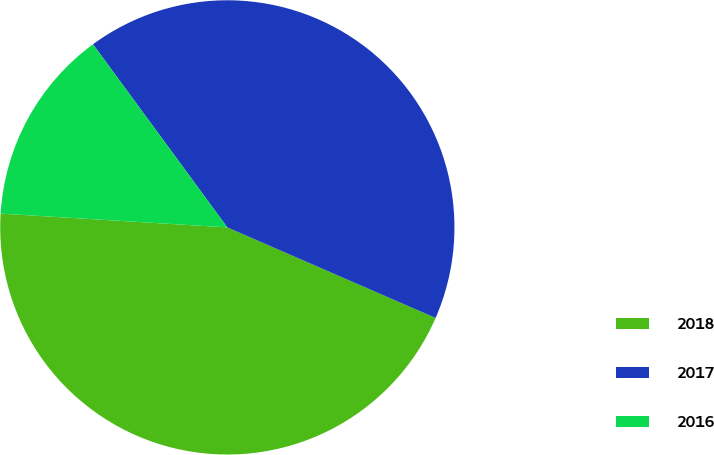Convert chart to OTSL. <chart><loc_0><loc_0><loc_500><loc_500><pie_chart><fcel>2018<fcel>2017<fcel>2016<nl><fcel>44.44%<fcel>41.6%<fcel>13.96%<nl></chart> 